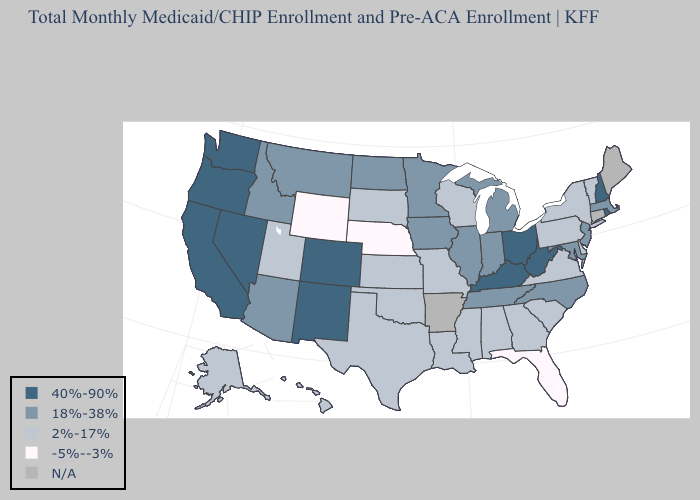What is the value of Rhode Island?
Keep it brief. 40%-90%. Among the states that border Arizona , does Utah have the highest value?
Short answer required. No. Name the states that have a value in the range -5%--3%?
Answer briefly. Florida, Nebraska, Wyoming. Does Florida have the lowest value in the South?
Concise answer only. Yes. What is the value of Arkansas?
Write a very short answer. N/A. Does the first symbol in the legend represent the smallest category?
Answer briefly. No. Does Ohio have the highest value in the USA?
Answer briefly. Yes. What is the highest value in the USA?
Keep it brief. 40%-90%. Name the states that have a value in the range 2%-17%?
Write a very short answer. Alabama, Alaska, Delaware, Georgia, Hawaii, Kansas, Louisiana, Mississippi, Missouri, New York, Oklahoma, Pennsylvania, South Carolina, South Dakota, Texas, Utah, Vermont, Virginia, Wisconsin. Name the states that have a value in the range -5%--3%?
Give a very brief answer. Florida, Nebraska, Wyoming. Among the states that border Pennsylvania , does New York have the highest value?
Write a very short answer. No. What is the lowest value in the West?
Give a very brief answer. -5%--3%. Among the states that border Kansas , which have the highest value?
Concise answer only. Colorado. What is the value of Michigan?
Write a very short answer. 18%-38%. Among the states that border Oklahoma , which have the lowest value?
Give a very brief answer. Kansas, Missouri, Texas. 